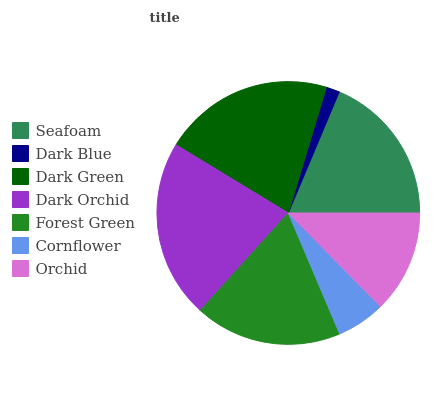Is Dark Blue the minimum?
Answer yes or no. Yes. Is Dark Orchid the maximum?
Answer yes or no. Yes. Is Dark Green the minimum?
Answer yes or no. No. Is Dark Green the maximum?
Answer yes or no. No. Is Dark Green greater than Dark Blue?
Answer yes or no. Yes. Is Dark Blue less than Dark Green?
Answer yes or no. Yes. Is Dark Blue greater than Dark Green?
Answer yes or no. No. Is Dark Green less than Dark Blue?
Answer yes or no. No. Is Forest Green the high median?
Answer yes or no. Yes. Is Forest Green the low median?
Answer yes or no. Yes. Is Dark Blue the high median?
Answer yes or no. No. Is Cornflower the low median?
Answer yes or no. No. 